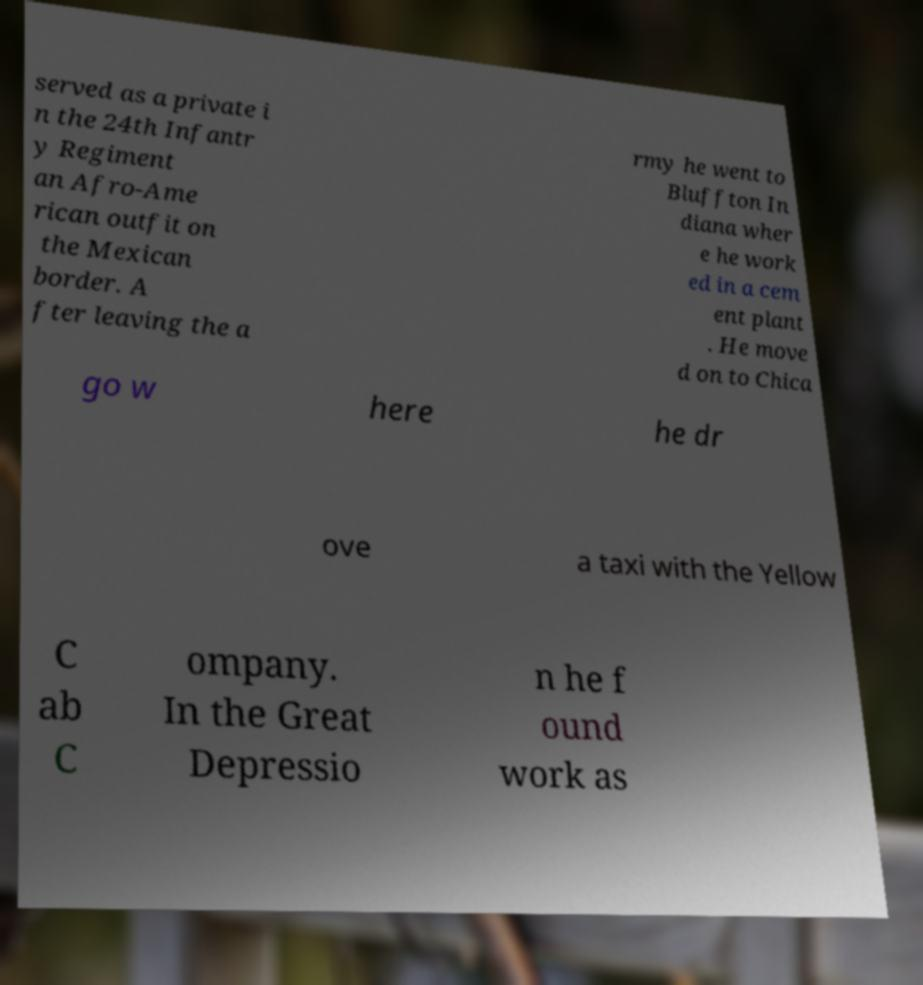What messages or text are displayed in this image? I need them in a readable, typed format. served as a private i n the 24th Infantr y Regiment an Afro-Ame rican outfit on the Mexican border. A fter leaving the a rmy he went to Bluffton In diana wher e he work ed in a cem ent plant . He move d on to Chica go w here he dr ove a taxi with the Yellow C ab C ompany. In the Great Depressio n he f ound work as 